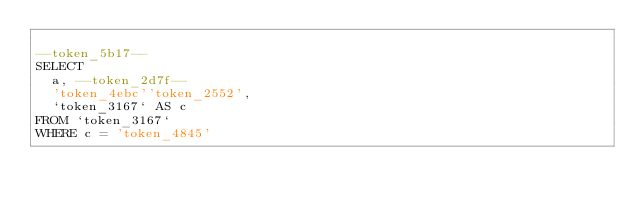<code> <loc_0><loc_0><loc_500><loc_500><_SQL_>
--token_5b17--
SELECT
  a, --token_2d7f--
  'token_4ebc''token_2552',
  `token_3167` AS c
FROM `token_3167`
WHERE c = 'token_4845'</code> 